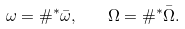<formula> <loc_0><loc_0><loc_500><loc_500>\omega = \# ^ { * } \bar { \omega } , \quad \Omega = \# ^ { * } \bar { \Omega } .</formula> 